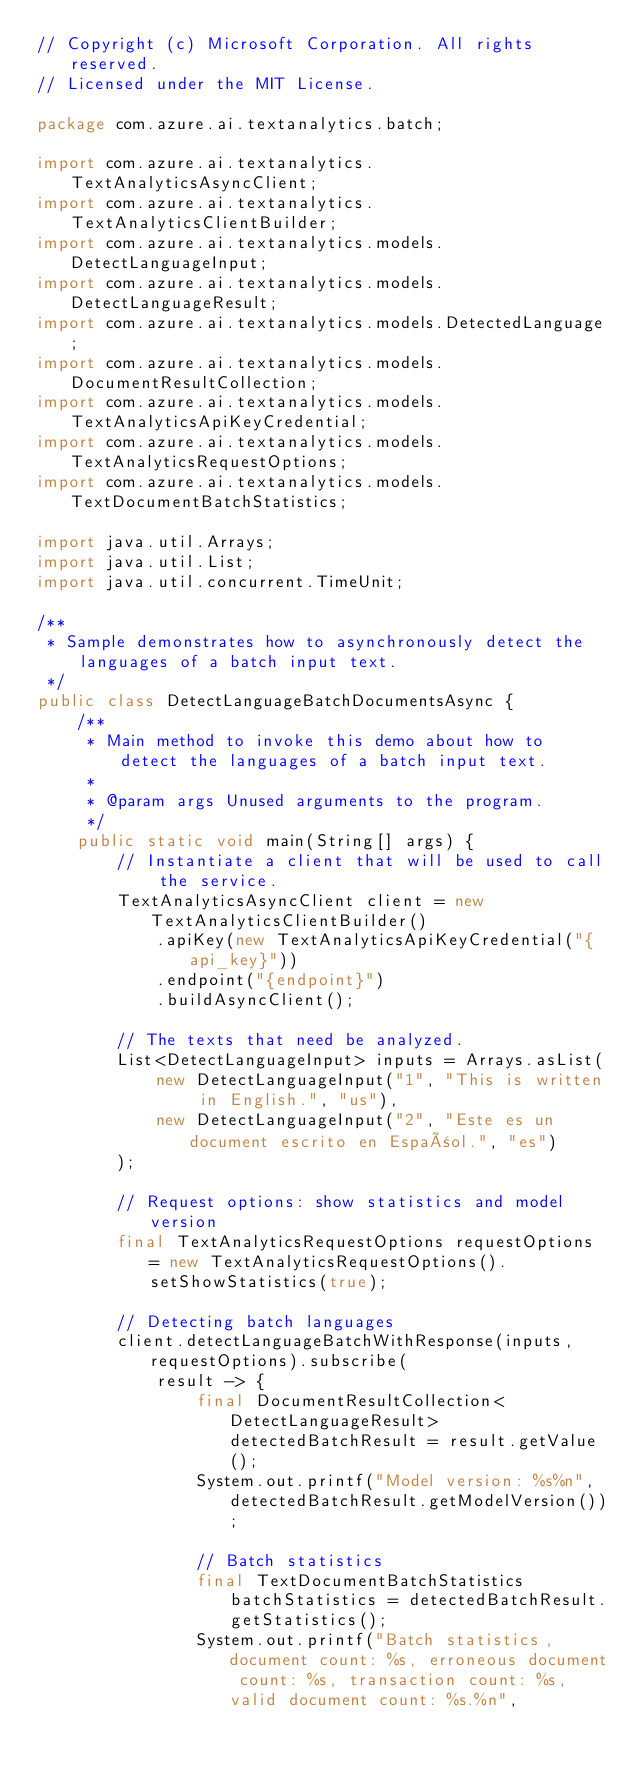<code> <loc_0><loc_0><loc_500><loc_500><_Java_>// Copyright (c) Microsoft Corporation. All rights reserved.
// Licensed under the MIT License.

package com.azure.ai.textanalytics.batch;

import com.azure.ai.textanalytics.TextAnalyticsAsyncClient;
import com.azure.ai.textanalytics.TextAnalyticsClientBuilder;
import com.azure.ai.textanalytics.models.DetectLanguageInput;
import com.azure.ai.textanalytics.models.DetectLanguageResult;
import com.azure.ai.textanalytics.models.DetectedLanguage;
import com.azure.ai.textanalytics.models.DocumentResultCollection;
import com.azure.ai.textanalytics.models.TextAnalyticsApiKeyCredential;
import com.azure.ai.textanalytics.models.TextAnalyticsRequestOptions;
import com.azure.ai.textanalytics.models.TextDocumentBatchStatistics;

import java.util.Arrays;
import java.util.List;
import java.util.concurrent.TimeUnit;

/**
 * Sample demonstrates how to asynchronously detect the languages of a batch input text.
 */
public class DetectLanguageBatchDocumentsAsync {
    /**
     * Main method to invoke this demo about how to detect the languages of a batch input text.
     *
     * @param args Unused arguments to the program.
     */
    public static void main(String[] args) {
        // Instantiate a client that will be used to call the service.
        TextAnalyticsAsyncClient client = new TextAnalyticsClientBuilder()
            .apiKey(new TextAnalyticsApiKeyCredential("{api_key}"))
            .endpoint("{endpoint}")
            .buildAsyncClient();

        // The texts that need be analyzed.
        List<DetectLanguageInput> inputs = Arrays.asList(
            new DetectLanguageInput("1", "This is written in English.", "us"),
            new DetectLanguageInput("2", "Este es un document escrito en Español.", "es")
        );

        // Request options: show statistics and model version
        final TextAnalyticsRequestOptions requestOptions = new TextAnalyticsRequestOptions().setShowStatistics(true);

        // Detecting batch languages
        client.detectLanguageBatchWithResponse(inputs, requestOptions).subscribe(
            result -> {
                final DocumentResultCollection<DetectLanguageResult> detectedBatchResult = result.getValue();
                System.out.printf("Model version: %s%n", detectedBatchResult.getModelVersion());

                // Batch statistics
                final TextDocumentBatchStatistics batchStatistics = detectedBatchResult.getStatistics();
                System.out.printf("Batch statistics, document count: %s, erroneous document count: %s, transaction count: %s, valid document count: %s.%n",</code> 